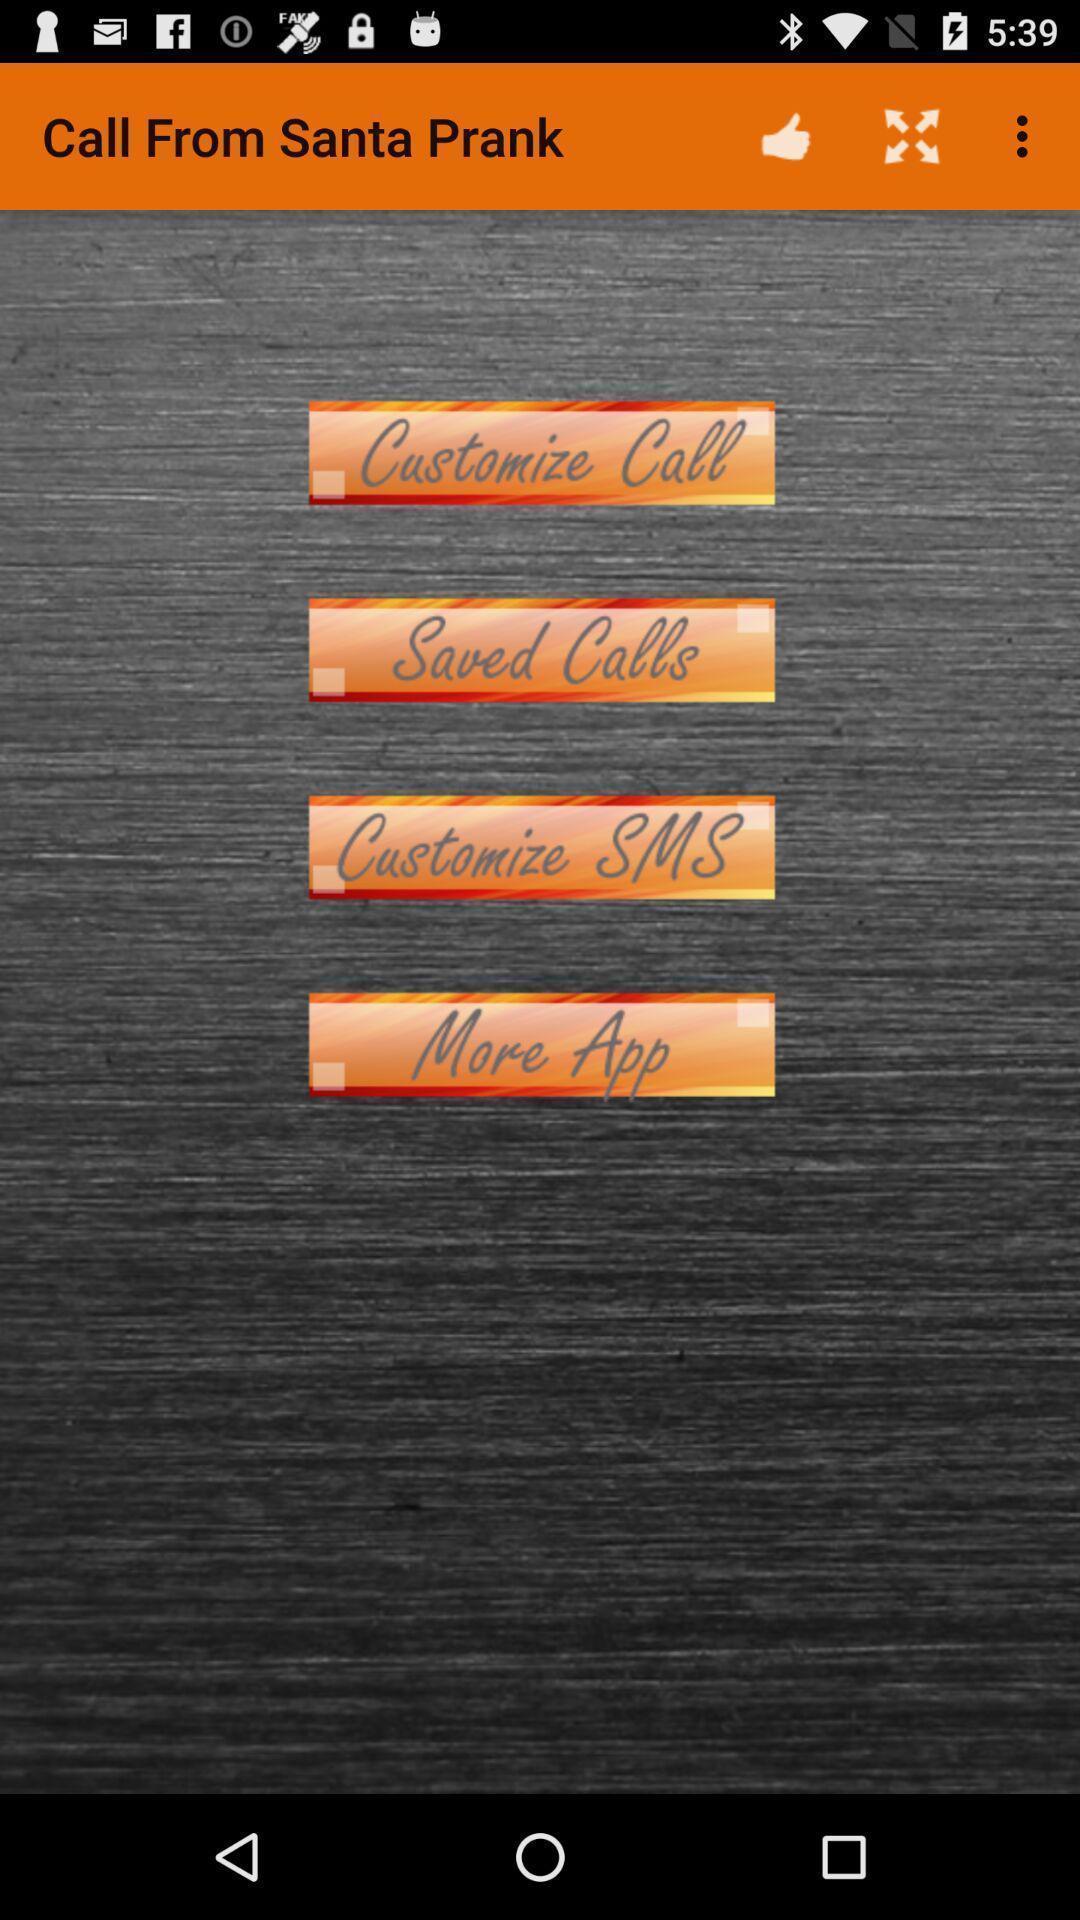Give me a summary of this screen capture. Page showing options of call app. 